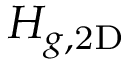<formula> <loc_0><loc_0><loc_500><loc_500>H _ { g , 2 D }</formula> 